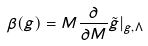<formula> <loc_0><loc_0><loc_500><loc_500>\beta ( g ) = M \frac { \partial } { \partial M } \tilde { g } | _ { g , \Lambda }</formula> 